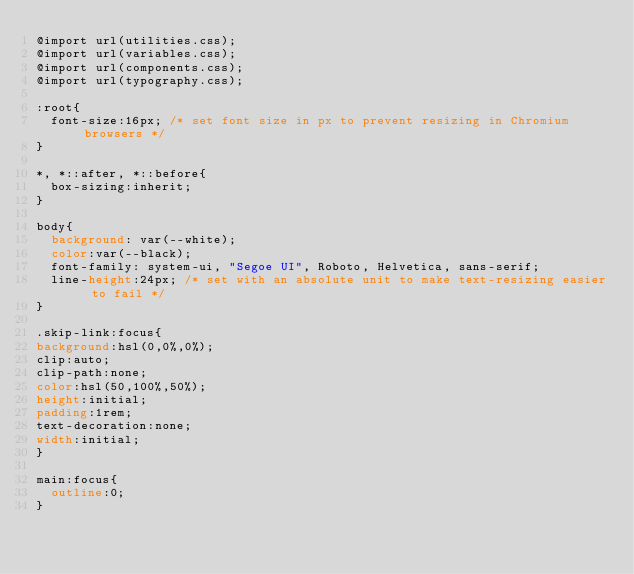<code> <loc_0><loc_0><loc_500><loc_500><_CSS_>@import url(utilities.css);
@import url(variables.css);
@import url(components.css);
@import url(typography.css);

:root{
  font-size:16px; /* set font size in px to prevent resizing in Chromium browsers */
}

*, *::after, *::before{
  box-sizing:inherit;
}

body{
  background: var(--white);
  color:var(--black);
  font-family: system-ui, "Segoe UI", Roboto, Helvetica, sans-serif;  
  line-height:24px; /* set with an absolute unit to make text-resizing easier to fail */
}

.skip-link:focus{
background:hsl(0,0%,0%);
clip:auto;
clip-path:none;
color:hsl(50,100%,50%);
height:initial;
padding:1rem;
text-decoration:none;
width:initial;
}

main:focus{
  outline:0;
}

</code> 